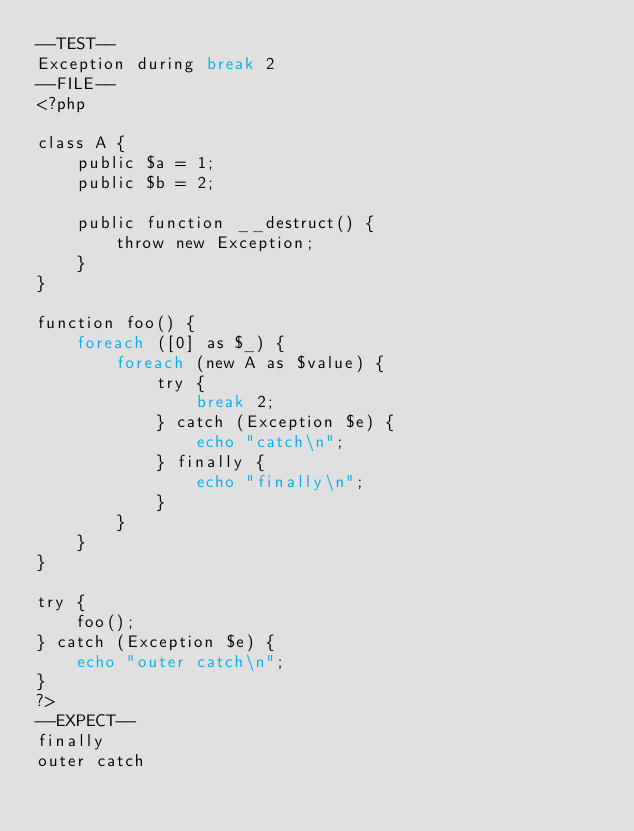<code> <loc_0><loc_0><loc_500><loc_500><_PHP_>--TEST--
Exception during break 2
--FILE--
<?php

class A {
    public $a = 1;
    public $b = 2;

    public function __destruct() {
        throw new Exception;
    }
}

function foo() {
    foreach ([0] as $_) {
        foreach (new A as $value) {
            try {
                break 2;
            } catch (Exception $e) {
                echo "catch\n";
            } finally {
                echo "finally\n";
            }
        }
    }
}

try {
    foo();
} catch (Exception $e) {
    echo "outer catch\n";
}
?>
--EXPECT--
finally
outer catch
</code> 